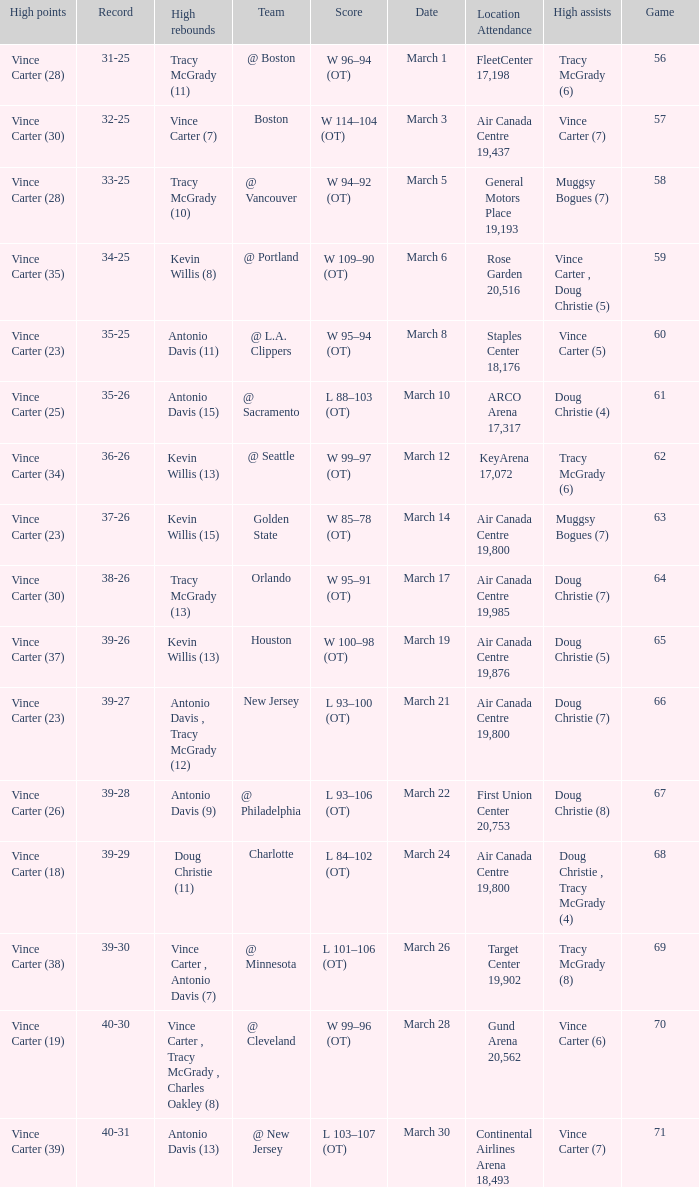Where did the team play and what was the attendance against new jersey? Air Canada Centre 19,800. Parse the table in full. {'header': ['High points', 'Record', 'High rebounds', 'Team', 'Score', 'Date', 'Location Attendance', 'High assists', 'Game'], 'rows': [['Vince Carter (28)', '31-25', 'Tracy McGrady (11)', '@ Boston', 'W 96–94 (OT)', 'March 1', 'FleetCenter 17,198', 'Tracy McGrady (6)', '56'], ['Vince Carter (30)', '32-25', 'Vince Carter (7)', 'Boston', 'W 114–104 (OT)', 'March 3', 'Air Canada Centre 19,437', 'Vince Carter (7)', '57'], ['Vince Carter (28)', '33-25', 'Tracy McGrady (10)', '@ Vancouver', 'W 94–92 (OT)', 'March 5', 'General Motors Place 19,193', 'Muggsy Bogues (7)', '58'], ['Vince Carter (35)', '34-25', 'Kevin Willis (8)', '@ Portland', 'W 109–90 (OT)', 'March 6', 'Rose Garden 20,516', 'Vince Carter , Doug Christie (5)', '59'], ['Vince Carter (23)', '35-25', 'Antonio Davis (11)', '@ L.A. Clippers', 'W 95–94 (OT)', 'March 8', 'Staples Center 18,176', 'Vince Carter (5)', '60'], ['Vince Carter (25)', '35-26', 'Antonio Davis (15)', '@ Sacramento', 'L 88–103 (OT)', 'March 10', 'ARCO Arena 17,317', 'Doug Christie (4)', '61'], ['Vince Carter (34)', '36-26', 'Kevin Willis (13)', '@ Seattle', 'W 99–97 (OT)', 'March 12', 'KeyArena 17,072', 'Tracy McGrady (6)', '62'], ['Vince Carter (23)', '37-26', 'Kevin Willis (15)', 'Golden State', 'W 85–78 (OT)', 'March 14', 'Air Canada Centre 19,800', 'Muggsy Bogues (7)', '63'], ['Vince Carter (30)', '38-26', 'Tracy McGrady (13)', 'Orlando', 'W 95–91 (OT)', 'March 17', 'Air Canada Centre 19,985', 'Doug Christie (7)', '64'], ['Vince Carter (37)', '39-26', 'Kevin Willis (13)', 'Houston', 'W 100–98 (OT)', 'March 19', 'Air Canada Centre 19,876', 'Doug Christie (5)', '65'], ['Vince Carter (23)', '39-27', 'Antonio Davis , Tracy McGrady (12)', 'New Jersey', 'L 93–100 (OT)', 'March 21', 'Air Canada Centre 19,800', 'Doug Christie (7)', '66'], ['Vince Carter (26)', '39-28', 'Antonio Davis (9)', '@ Philadelphia', 'L 93–106 (OT)', 'March 22', 'First Union Center 20,753', 'Doug Christie (8)', '67'], ['Vince Carter (18)', '39-29', 'Doug Christie (11)', 'Charlotte', 'L 84–102 (OT)', 'March 24', 'Air Canada Centre 19,800', 'Doug Christie , Tracy McGrady (4)', '68'], ['Vince Carter (38)', '39-30', 'Vince Carter , Antonio Davis (7)', '@ Minnesota', 'L 101–106 (OT)', 'March 26', 'Target Center 19,902', 'Tracy McGrady (8)', '69'], ['Vince Carter (19)', '40-30', 'Vince Carter , Tracy McGrady , Charles Oakley (8)', '@ Cleveland', 'W 99–96 (OT)', 'March 28', 'Gund Arena 20,562', 'Vince Carter (6)', '70'], ['Vince Carter (39)', '40-31', 'Antonio Davis (13)', '@ New Jersey', 'L 103–107 (OT)', 'March 30', 'Continental Airlines Arena 18,493', 'Vince Carter (7)', '71']]} 